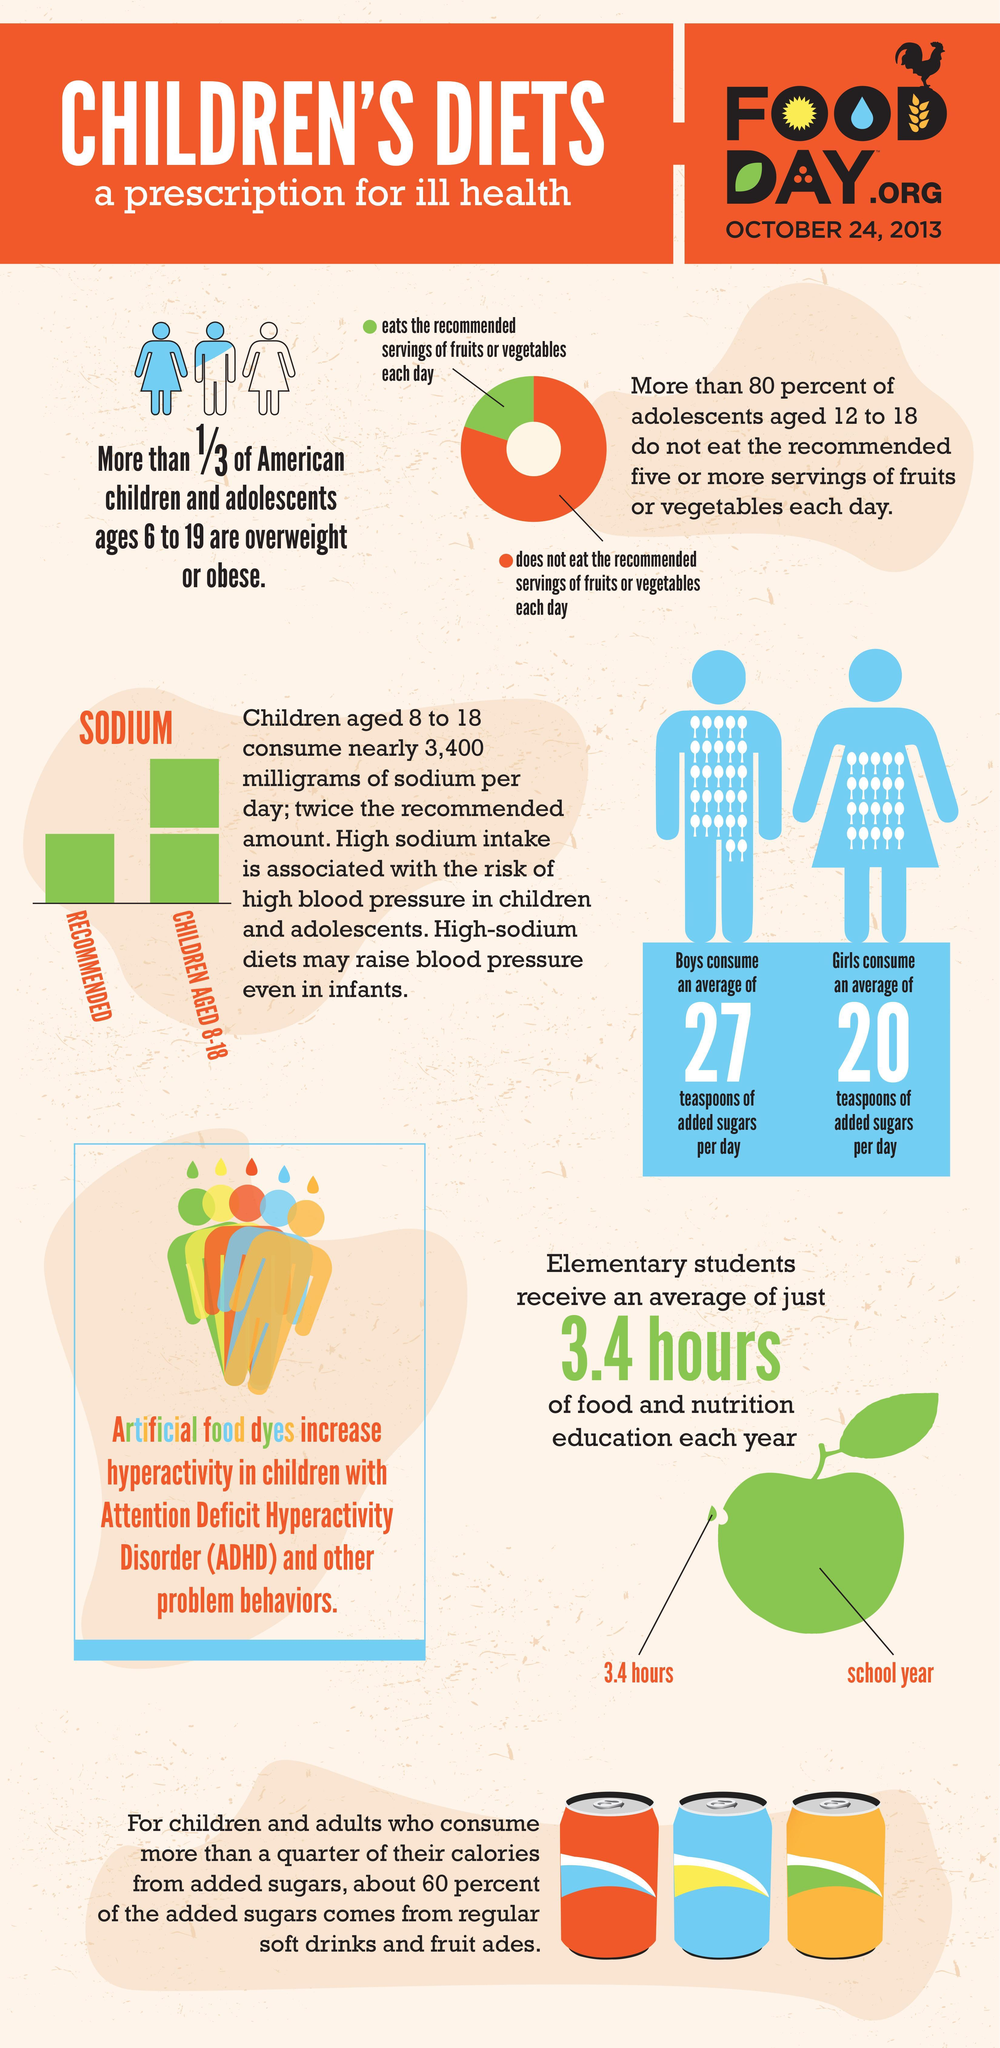Which food items are the most common sources of added sugar?
Answer the question with a short phrase. soft drinks and fruit ades What is the average sugar consumption of Girls per day? 20 teaspoons What is the color code given for children who eats fruits and veggies in a day- yellow, orange, white, green? green 